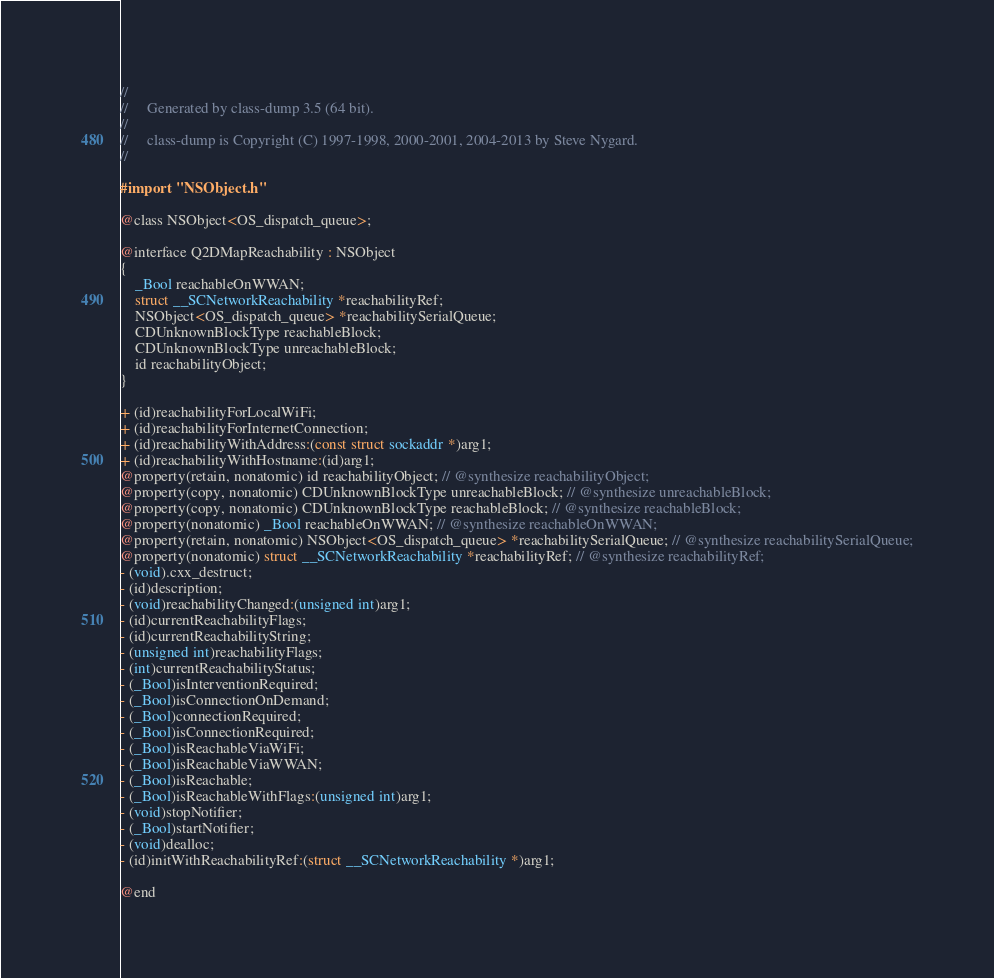<code> <loc_0><loc_0><loc_500><loc_500><_C_>//
//     Generated by class-dump 3.5 (64 bit).
//
//     class-dump is Copyright (C) 1997-1998, 2000-2001, 2004-2013 by Steve Nygard.
//

#import "NSObject.h"

@class NSObject<OS_dispatch_queue>;

@interface Q2DMapReachability : NSObject
{
    _Bool reachableOnWWAN;
    struct __SCNetworkReachability *reachabilityRef;
    NSObject<OS_dispatch_queue> *reachabilitySerialQueue;
    CDUnknownBlockType reachableBlock;
    CDUnknownBlockType unreachableBlock;
    id reachabilityObject;
}

+ (id)reachabilityForLocalWiFi;
+ (id)reachabilityForInternetConnection;
+ (id)reachabilityWithAddress:(const struct sockaddr *)arg1;
+ (id)reachabilityWithHostname:(id)arg1;
@property(retain, nonatomic) id reachabilityObject; // @synthesize reachabilityObject;
@property(copy, nonatomic) CDUnknownBlockType unreachableBlock; // @synthesize unreachableBlock;
@property(copy, nonatomic) CDUnknownBlockType reachableBlock; // @synthesize reachableBlock;
@property(nonatomic) _Bool reachableOnWWAN; // @synthesize reachableOnWWAN;
@property(retain, nonatomic) NSObject<OS_dispatch_queue> *reachabilitySerialQueue; // @synthesize reachabilitySerialQueue;
@property(nonatomic) struct __SCNetworkReachability *reachabilityRef; // @synthesize reachabilityRef;
- (void).cxx_destruct;
- (id)description;
- (void)reachabilityChanged:(unsigned int)arg1;
- (id)currentReachabilityFlags;
- (id)currentReachabilityString;
- (unsigned int)reachabilityFlags;
- (int)currentReachabilityStatus;
- (_Bool)isInterventionRequired;
- (_Bool)isConnectionOnDemand;
- (_Bool)connectionRequired;
- (_Bool)isConnectionRequired;
- (_Bool)isReachableViaWiFi;
- (_Bool)isReachableViaWWAN;
- (_Bool)isReachable;
- (_Bool)isReachableWithFlags:(unsigned int)arg1;
- (void)stopNotifier;
- (_Bool)startNotifier;
- (void)dealloc;
- (id)initWithReachabilityRef:(struct __SCNetworkReachability *)arg1;

@end

</code> 